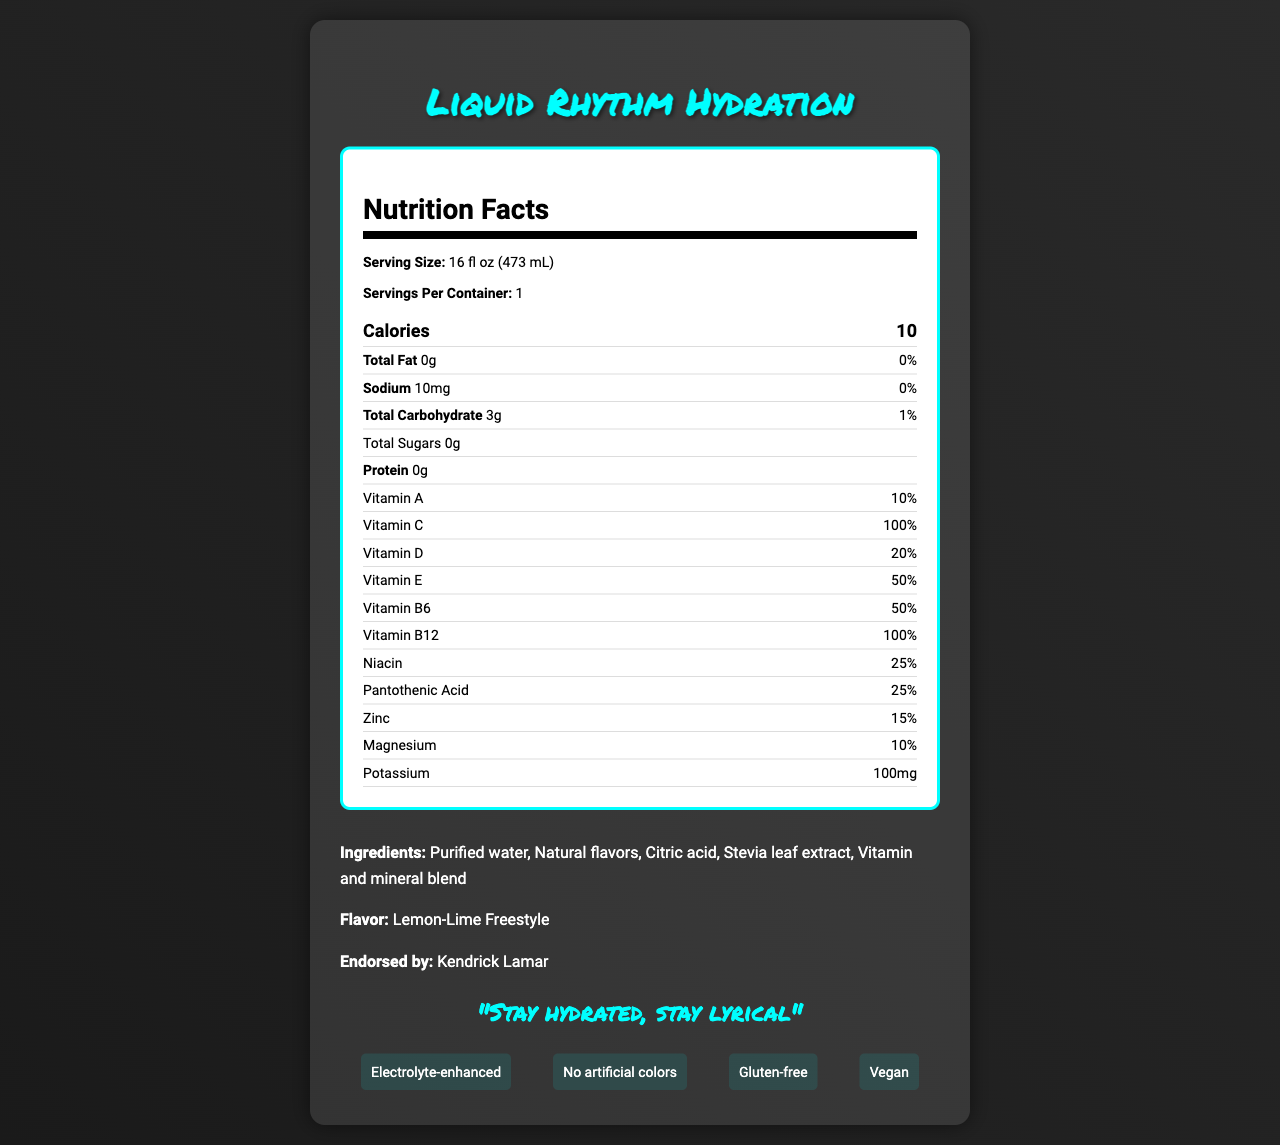what is the serving size? The serving size is clearly listed as "16 fl oz (473 mL)" under the Nutrition Facts section.
Answer: 16 fl oz (473 mL) who is endorsing this product? The document mentions that the product is endorsed by Kendrick Lamar in the additional information section.
Answer: Kendrick Lamar what is the total carbohydrate content? The total carbohydrate content is listed as "3g" in the Nutrition Facts section.
Answer: 3g how much protein does the product contain? The Nutrition Facts section shows that the protein content is "0g".
Answer: 0g what is the percentage of daily value for Vitamin C? The daily value percentage for Vitamin C is listed as "100%" in the Nutrition Facts section.
Answer: 100% what is the flavor of this vitamin-fortified water? The flavor is mentioned as "Lemon-Lime Freestyle" in the additional information section.
Answer: Lemon-Lime Freestyle which of the following vitamins has the highest daily value percentage? A. Vitamin A B. Vitamin C C. Vitamin D D. Vitamin E Vitamin C has a daily value percentage of 100%, which is the highest among the listed vitamins.
Answer: B. Vitamin C what is the main slogan for Liquid Rhythm Hydration? The slogan is clearly mentioned as "Stay hydrated, stay lyrical" in the document.
Answer: Stay hydrated, stay lyrical which one of these is not a special feature of the product? A. Electrolyte-enhanced B. Contains artificial colors C. Gluten-free D. Vegan The document states that the product has "No artificial colors", making option B the correct answer.
Answer: B. Contains artificial colors is this product suitable for vegans? The document lists "Vegan" as one of the special features, confirming its suitability for vegans.
Answer: Yes what ingredient is not listed in the product? The document lists the ingredients, and sugar is not included among them.
Answer: Sugar how does the product contribute to social impact? The document mentions that a portion of the proceeds is donated to urban music education programs.
Answer: Portion of proceeds donated to urban music education programs is this product carbon-neutral? The document states that the production process is carbon-neutral.
Answer: Yes how many calories are in one serving of Liquid Rhythm Hydration? The document lists "10 calories" in the Nutrition Facts section.
Answer: 10 calories describe the main idea of the document. The document is focused on presenting all relevant aspects of the product, from its nutritional benefits and special features to its social impact and endorsements, aiming to inform and attract its target audience.
Answer: The document provides detailed information on Liquid Rhythm Hydration, a vitamin-fortified water endorsed by Kendrick Lamar, including its nutritional content, special features, ingredients, flavor, slogan, sustainability practices, target audience, packaging, and social impact. how much sodium is in the product? The document states that the sodium content is "10mg".
Answer: 10mg what is the portion of potassium in this product? The document's Nutrition Facts section lists 100mg of potassium.
Answer: 100mg when was the product awarded Best New Beverage at Urban Music Awards? The document states that the product won the award in 2023.
Answer: 2023 what are the total sugars in the product? The Nutrition Facts section lists total sugars as "0g".
Answer: 0g which vitamin has the same daily value percentage as Vitamin B12? Both Vitamin B12 and Vitamin C have a daily value of 100%.
Answer: Vitamin C can you determine the cost of this product from the document? The document does not provide any pricing or cost details.
Answer: Not enough information 